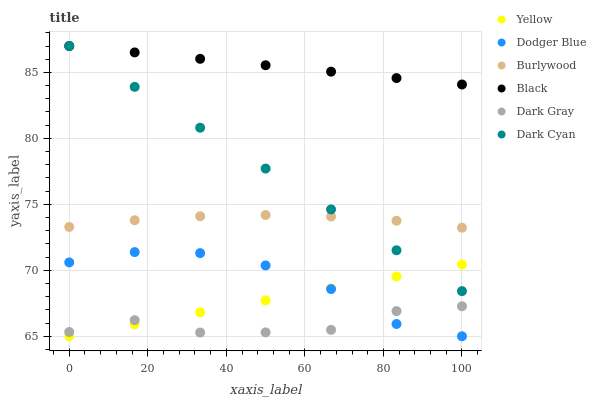Does Dark Gray have the minimum area under the curve?
Answer yes or no. Yes. Does Black have the maximum area under the curve?
Answer yes or no. Yes. Does Yellow have the minimum area under the curve?
Answer yes or no. No. Does Yellow have the maximum area under the curve?
Answer yes or no. No. Is Dark Cyan the smoothest?
Answer yes or no. Yes. Is Dark Gray the roughest?
Answer yes or no. Yes. Is Yellow the smoothest?
Answer yes or no. No. Is Yellow the roughest?
Answer yes or no. No. Does Yellow have the lowest value?
Answer yes or no. Yes. Does Dark Gray have the lowest value?
Answer yes or no. No. Does Dark Cyan have the highest value?
Answer yes or no. Yes. Does Yellow have the highest value?
Answer yes or no. No. Is Dodger Blue less than Burlywood?
Answer yes or no. Yes. Is Dark Cyan greater than Dodger Blue?
Answer yes or no. Yes. Does Yellow intersect Dark Cyan?
Answer yes or no. Yes. Is Yellow less than Dark Cyan?
Answer yes or no. No. Is Yellow greater than Dark Cyan?
Answer yes or no. No. Does Dodger Blue intersect Burlywood?
Answer yes or no. No. 